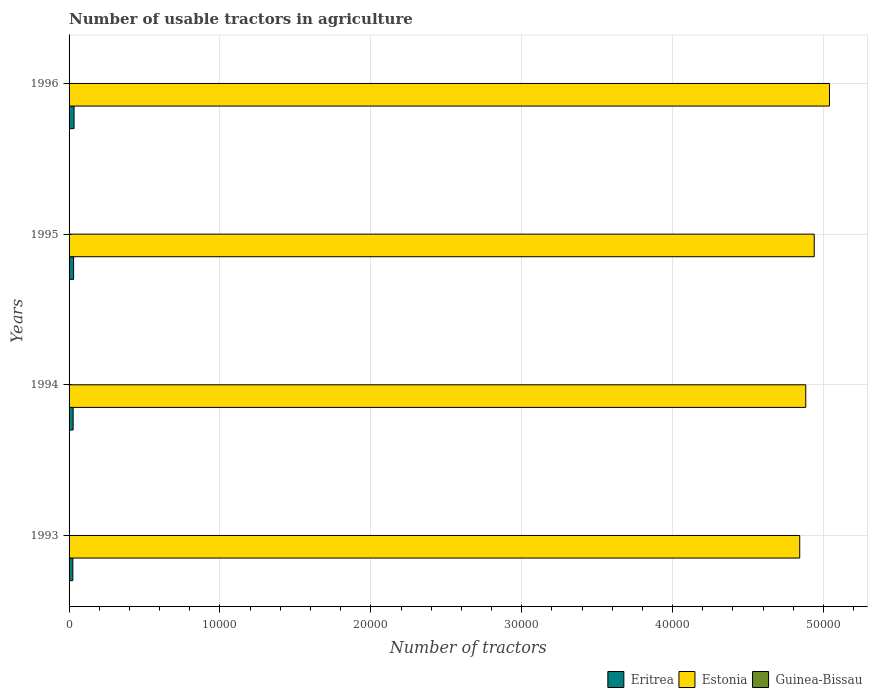How many groups of bars are there?
Make the answer very short. 4. Are the number of bars on each tick of the Y-axis equal?
Your answer should be very brief. Yes. How many bars are there on the 4th tick from the bottom?
Provide a short and direct response. 3. In how many cases, is the number of bars for a given year not equal to the number of legend labels?
Ensure brevity in your answer.  0. Across all years, what is the maximum number of usable tractors in agriculture in Eritrea?
Your response must be concise. 331. Across all years, what is the minimum number of usable tractors in agriculture in Guinea-Bissau?
Your answer should be compact. 19. What is the total number of usable tractors in agriculture in Estonia in the graph?
Your answer should be very brief. 1.97e+05. What is the difference between the number of usable tractors in agriculture in Estonia in 1994 and the number of usable tractors in agriculture in Guinea-Bissau in 1996?
Your answer should be very brief. 4.88e+04. What is the average number of usable tractors in agriculture in Estonia per year?
Provide a short and direct response. 4.93e+04. In the year 1996, what is the difference between the number of usable tractors in agriculture in Guinea-Bissau and number of usable tractors in agriculture in Eritrea?
Offer a terse response. -312. What is the ratio of the number of usable tractors in agriculture in Eritrea in 1994 to that in 1996?
Offer a very short reply. 0.82. What is the difference between the highest and the second highest number of usable tractors in agriculture in Estonia?
Offer a terse response. 1011. What is the difference between the highest and the lowest number of usable tractors in agriculture in Estonia?
Provide a succinct answer. 1972. Is the sum of the number of usable tractors in agriculture in Guinea-Bissau in 1994 and 1996 greater than the maximum number of usable tractors in agriculture in Estonia across all years?
Provide a succinct answer. No. What does the 1st bar from the top in 1995 represents?
Offer a very short reply. Guinea-Bissau. What does the 2nd bar from the bottom in 1995 represents?
Offer a terse response. Estonia. How many years are there in the graph?
Ensure brevity in your answer.  4. What is the difference between two consecutive major ticks on the X-axis?
Keep it short and to the point. 10000. Does the graph contain any zero values?
Provide a short and direct response. No. Where does the legend appear in the graph?
Provide a succinct answer. Bottom right. What is the title of the graph?
Offer a terse response. Number of usable tractors in agriculture. Does "Vietnam" appear as one of the legend labels in the graph?
Provide a short and direct response. No. What is the label or title of the X-axis?
Make the answer very short. Number of tractors. What is the label or title of the Y-axis?
Ensure brevity in your answer.  Years. What is the Number of tractors of Eritrea in 1993?
Ensure brevity in your answer.  250. What is the Number of tractors of Estonia in 1993?
Provide a short and direct response. 4.84e+04. What is the Number of tractors in Guinea-Bissau in 1993?
Your answer should be very brief. 19. What is the Number of tractors of Eritrea in 1994?
Your response must be concise. 270. What is the Number of tractors of Estonia in 1994?
Give a very brief answer. 4.88e+04. What is the Number of tractors of Guinea-Bissau in 1994?
Give a very brief answer. 19. What is the Number of tractors in Eritrea in 1995?
Keep it short and to the point. 300. What is the Number of tractors in Estonia in 1995?
Give a very brief answer. 4.94e+04. What is the Number of tractors of Eritrea in 1996?
Offer a terse response. 331. What is the Number of tractors in Estonia in 1996?
Keep it short and to the point. 5.04e+04. Across all years, what is the maximum Number of tractors in Eritrea?
Your answer should be compact. 331. Across all years, what is the maximum Number of tractors in Estonia?
Your answer should be compact. 5.04e+04. Across all years, what is the minimum Number of tractors in Eritrea?
Ensure brevity in your answer.  250. Across all years, what is the minimum Number of tractors of Estonia?
Your answer should be very brief. 4.84e+04. Across all years, what is the minimum Number of tractors of Guinea-Bissau?
Provide a succinct answer. 19. What is the total Number of tractors of Eritrea in the graph?
Your answer should be very brief. 1151. What is the total Number of tractors of Estonia in the graph?
Your answer should be very brief. 1.97e+05. What is the difference between the Number of tractors of Estonia in 1993 and that in 1994?
Your response must be concise. -400. What is the difference between the Number of tractors in Guinea-Bissau in 1993 and that in 1994?
Offer a terse response. 0. What is the difference between the Number of tractors of Estonia in 1993 and that in 1995?
Your answer should be very brief. -961. What is the difference between the Number of tractors of Guinea-Bissau in 1993 and that in 1995?
Your answer should be compact. 0. What is the difference between the Number of tractors in Eritrea in 1993 and that in 1996?
Make the answer very short. -81. What is the difference between the Number of tractors in Estonia in 1993 and that in 1996?
Your response must be concise. -1972. What is the difference between the Number of tractors of Eritrea in 1994 and that in 1995?
Provide a succinct answer. -30. What is the difference between the Number of tractors in Estonia in 1994 and that in 1995?
Your response must be concise. -561. What is the difference between the Number of tractors of Eritrea in 1994 and that in 1996?
Offer a very short reply. -61. What is the difference between the Number of tractors of Estonia in 1994 and that in 1996?
Your answer should be compact. -1572. What is the difference between the Number of tractors of Guinea-Bissau in 1994 and that in 1996?
Your answer should be compact. 0. What is the difference between the Number of tractors of Eritrea in 1995 and that in 1996?
Your answer should be very brief. -31. What is the difference between the Number of tractors of Estonia in 1995 and that in 1996?
Keep it short and to the point. -1011. What is the difference between the Number of tractors of Guinea-Bissau in 1995 and that in 1996?
Keep it short and to the point. 0. What is the difference between the Number of tractors of Eritrea in 1993 and the Number of tractors of Estonia in 1994?
Provide a short and direct response. -4.86e+04. What is the difference between the Number of tractors of Eritrea in 1993 and the Number of tractors of Guinea-Bissau in 1994?
Provide a succinct answer. 231. What is the difference between the Number of tractors in Estonia in 1993 and the Number of tractors in Guinea-Bissau in 1994?
Make the answer very short. 4.84e+04. What is the difference between the Number of tractors in Eritrea in 1993 and the Number of tractors in Estonia in 1995?
Ensure brevity in your answer.  -4.91e+04. What is the difference between the Number of tractors of Eritrea in 1993 and the Number of tractors of Guinea-Bissau in 1995?
Give a very brief answer. 231. What is the difference between the Number of tractors in Estonia in 1993 and the Number of tractors in Guinea-Bissau in 1995?
Provide a succinct answer. 4.84e+04. What is the difference between the Number of tractors in Eritrea in 1993 and the Number of tractors in Estonia in 1996?
Offer a very short reply. -5.01e+04. What is the difference between the Number of tractors in Eritrea in 1993 and the Number of tractors in Guinea-Bissau in 1996?
Offer a terse response. 231. What is the difference between the Number of tractors in Estonia in 1993 and the Number of tractors in Guinea-Bissau in 1996?
Make the answer very short. 4.84e+04. What is the difference between the Number of tractors in Eritrea in 1994 and the Number of tractors in Estonia in 1995?
Offer a very short reply. -4.91e+04. What is the difference between the Number of tractors of Eritrea in 1994 and the Number of tractors of Guinea-Bissau in 1995?
Provide a succinct answer. 251. What is the difference between the Number of tractors of Estonia in 1994 and the Number of tractors of Guinea-Bissau in 1995?
Your response must be concise. 4.88e+04. What is the difference between the Number of tractors in Eritrea in 1994 and the Number of tractors in Estonia in 1996?
Give a very brief answer. -5.01e+04. What is the difference between the Number of tractors in Eritrea in 1994 and the Number of tractors in Guinea-Bissau in 1996?
Keep it short and to the point. 251. What is the difference between the Number of tractors of Estonia in 1994 and the Number of tractors of Guinea-Bissau in 1996?
Ensure brevity in your answer.  4.88e+04. What is the difference between the Number of tractors of Eritrea in 1995 and the Number of tractors of Estonia in 1996?
Provide a short and direct response. -5.01e+04. What is the difference between the Number of tractors of Eritrea in 1995 and the Number of tractors of Guinea-Bissau in 1996?
Your response must be concise. 281. What is the difference between the Number of tractors in Estonia in 1995 and the Number of tractors in Guinea-Bissau in 1996?
Make the answer very short. 4.94e+04. What is the average Number of tractors of Eritrea per year?
Ensure brevity in your answer.  287.75. What is the average Number of tractors in Estonia per year?
Make the answer very short. 4.93e+04. What is the average Number of tractors of Guinea-Bissau per year?
Your answer should be compact. 19. In the year 1993, what is the difference between the Number of tractors of Eritrea and Number of tractors of Estonia?
Your answer should be very brief. -4.82e+04. In the year 1993, what is the difference between the Number of tractors of Eritrea and Number of tractors of Guinea-Bissau?
Your answer should be very brief. 231. In the year 1993, what is the difference between the Number of tractors in Estonia and Number of tractors in Guinea-Bissau?
Offer a very short reply. 4.84e+04. In the year 1994, what is the difference between the Number of tractors of Eritrea and Number of tractors of Estonia?
Ensure brevity in your answer.  -4.86e+04. In the year 1994, what is the difference between the Number of tractors in Eritrea and Number of tractors in Guinea-Bissau?
Offer a very short reply. 251. In the year 1994, what is the difference between the Number of tractors of Estonia and Number of tractors of Guinea-Bissau?
Your answer should be compact. 4.88e+04. In the year 1995, what is the difference between the Number of tractors in Eritrea and Number of tractors in Estonia?
Your response must be concise. -4.91e+04. In the year 1995, what is the difference between the Number of tractors in Eritrea and Number of tractors in Guinea-Bissau?
Your response must be concise. 281. In the year 1995, what is the difference between the Number of tractors in Estonia and Number of tractors in Guinea-Bissau?
Offer a very short reply. 4.94e+04. In the year 1996, what is the difference between the Number of tractors of Eritrea and Number of tractors of Estonia?
Make the answer very short. -5.01e+04. In the year 1996, what is the difference between the Number of tractors in Eritrea and Number of tractors in Guinea-Bissau?
Offer a very short reply. 312. In the year 1996, what is the difference between the Number of tractors in Estonia and Number of tractors in Guinea-Bissau?
Provide a succinct answer. 5.04e+04. What is the ratio of the Number of tractors of Eritrea in 1993 to that in 1994?
Your answer should be very brief. 0.93. What is the ratio of the Number of tractors in Estonia in 1993 to that in 1994?
Your response must be concise. 0.99. What is the ratio of the Number of tractors in Guinea-Bissau in 1993 to that in 1994?
Your response must be concise. 1. What is the ratio of the Number of tractors in Eritrea in 1993 to that in 1995?
Your answer should be very brief. 0.83. What is the ratio of the Number of tractors in Estonia in 1993 to that in 1995?
Provide a short and direct response. 0.98. What is the ratio of the Number of tractors of Guinea-Bissau in 1993 to that in 1995?
Your answer should be compact. 1. What is the ratio of the Number of tractors in Eritrea in 1993 to that in 1996?
Your answer should be compact. 0.76. What is the ratio of the Number of tractors in Estonia in 1993 to that in 1996?
Ensure brevity in your answer.  0.96. What is the ratio of the Number of tractors of Guinea-Bissau in 1993 to that in 1996?
Your answer should be very brief. 1. What is the ratio of the Number of tractors of Eritrea in 1994 to that in 1995?
Your answer should be very brief. 0.9. What is the ratio of the Number of tractors in Eritrea in 1994 to that in 1996?
Make the answer very short. 0.82. What is the ratio of the Number of tractors in Estonia in 1994 to that in 1996?
Provide a succinct answer. 0.97. What is the ratio of the Number of tractors in Guinea-Bissau in 1994 to that in 1996?
Give a very brief answer. 1. What is the ratio of the Number of tractors in Eritrea in 1995 to that in 1996?
Offer a terse response. 0.91. What is the ratio of the Number of tractors in Estonia in 1995 to that in 1996?
Make the answer very short. 0.98. What is the difference between the highest and the second highest Number of tractors in Estonia?
Offer a terse response. 1011. What is the difference between the highest and the second highest Number of tractors in Guinea-Bissau?
Your response must be concise. 0. What is the difference between the highest and the lowest Number of tractors in Estonia?
Give a very brief answer. 1972. 